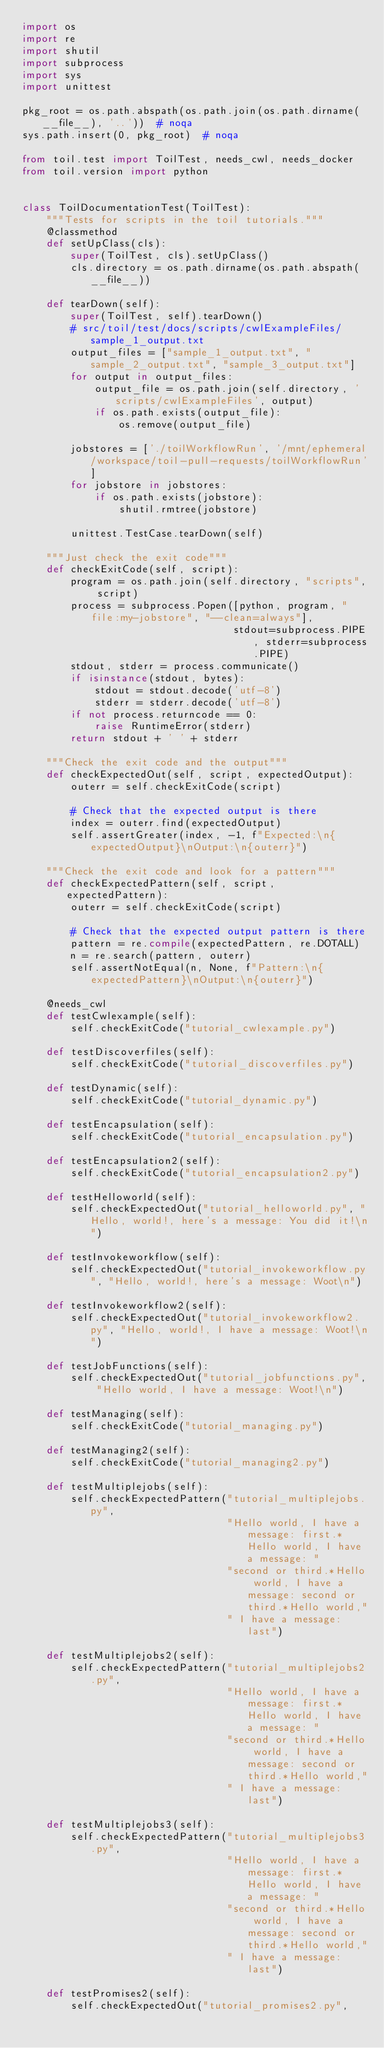Convert code to text. <code><loc_0><loc_0><loc_500><loc_500><_Python_>import os
import re
import shutil
import subprocess
import sys
import unittest

pkg_root = os.path.abspath(os.path.join(os.path.dirname(__file__), '..'))  # noqa
sys.path.insert(0, pkg_root)  # noqa

from toil.test import ToilTest, needs_cwl, needs_docker
from toil.version import python


class ToilDocumentationTest(ToilTest):
    """Tests for scripts in the toil tutorials."""
    @classmethod
    def setUpClass(cls):
        super(ToilTest, cls).setUpClass()
        cls.directory = os.path.dirname(os.path.abspath(__file__))

    def tearDown(self):
        super(ToilTest, self).tearDown()
        # src/toil/test/docs/scripts/cwlExampleFiles/sample_1_output.txt
        output_files = ["sample_1_output.txt", "sample_2_output.txt", "sample_3_output.txt"]
        for output in output_files:
            output_file = os.path.join(self.directory, 'scripts/cwlExampleFiles', output)
            if os.path.exists(output_file):
                os.remove(output_file)

        jobstores = ['./toilWorkflowRun', '/mnt/ephemeral/workspace/toil-pull-requests/toilWorkflowRun']
        for jobstore in jobstores:
            if os.path.exists(jobstore):
                shutil.rmtree(jobstore)

        unittest.TestCase.tearDown(self)

    """Just check the exit code"""
    def checkExitCode(self, script):
        program = os.path.join(self.directory, "scripts", script)
        process = subprocess.Popen([python, program, "file:my-jobstore", "--clean=always"],
                                   stdout=subprocess.PIPE, stderr=subprocess.PIPE)
        stdout, stderr = process.communicate()
        if isinstance(stdout, bytes):
            stdout = stdout.decode('utf-8')
            stderr = stderr.decode('utf-8')
        if not process.returncode == 0:
            raise RuntimeError(stderr)
        return stdout + ' ' + stderr

    """Check the exit code and the output"""
    def checkExpectedOut(self, script, expectedOutput):
        outerr = self.checkExitCode(script)

        # Check that the expected output is there
        index = outerr.find(expectedOutput)
        self.assertGreater(index, -1, f"Expected:\n{expectedOutput}\nOutput:\n{outerr}")

    """Check the exit code and look for a pattern"""
    def checkExpectedPattern(self, script, expectedPattern):
        outerr = self.checkExitCode(script)

        # Check that the expected output pattern is there
        pattern = re.compile(expectedPattern, re.DOTALL)
        n = re.search(pattern, outerr)
        self.assertNotEqual(n, None, f"Pattern:\n{expectedPattern}\nOutput:\n{outerr}")

    @needs_cwl
    def testCwlexample(self):
        self.checkExitCode("tutorial_cwlexample.py")

    def testDiscoverfiles(self):
        self.checkExitCode("tutorial_discoverfiles.py")

    def testDynamic(self):
        self.checkExitCode("tutorial_dynamic.py")

    def testEncapsulation(self):
        self.checkExitCode("tutorial_encapsulation.py")

    def testEncapsulation2(self):
        self.checkExitCode("tutorial_encapsulation2.py")

    def testHelloworld(self):
        self.checkExpectedOut("tutorial_helloworld.py", "Hello, world!, here's a message: You did it!\n")

    def testInvokeworkflow(self):
        self.checkExpectedOut("tutorial_invokeworkflow.py", "Hello, world!, here's a message: Woot\n")

    def testInvokeworkflow2(self):
        self.checkExpectedOut("tutorial_invokeworkflow2.py", "Hello, world!, I have a message: Woot!\n")

    def testJobFunctions(self):
        self.checkExpectedOut("tutorial_jobfunctions.py", "Hello world, I have a message: Woot!\n")

    def testManaging(self):
        self.checkExitCode("tutorial_managing.py")

    def testManaging2(self):
        self.checkExitCode("tutorial_managing2.py")

    def testMultiplejobs(self):
        self.checkExpectedPattern("tutorial_multiplejobs.py",
                                  "Hello world, I have a message: first.*Hello world, I have a message: "
                                  "second or third.*Hello world, I have a message: second or third.*Hello world,"
                                  " I have a message: last")

    def testMultiplejobs2(self):
        self.checkExpectedPattern("tutorial_multiplejobs2.py",
                                  "Hello world, I have a message: first.*Hello world, I have a message: "
                                  "second or third.*Hello world, I have a message: second or third.*Hello world,"
                                  " I have a message: last")

    def testMultiplejobs3(self):
        self.checkExpectedPattern("tutorial_multiplejobs3.py",
                                  "Hello world, I have a message: first.*Hello world, I have a message: "
                                  "second or third.*Hello world, I have a message: second or third.*Hello world,"
                                  " I have a message: last")

    def testPromises2(self):
        self.checkExpectedOut("tutorial_promises2.py",</code> 